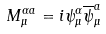Convert formula to latex. <formula><loc_0><loc_0><loc_500><loc_500>M ^ { \alpha a } _ { \mu } = i \psi ^ { \alpha } _ { \mu } \overline { \psi } ^ { a } _ { \mu }</formula> 